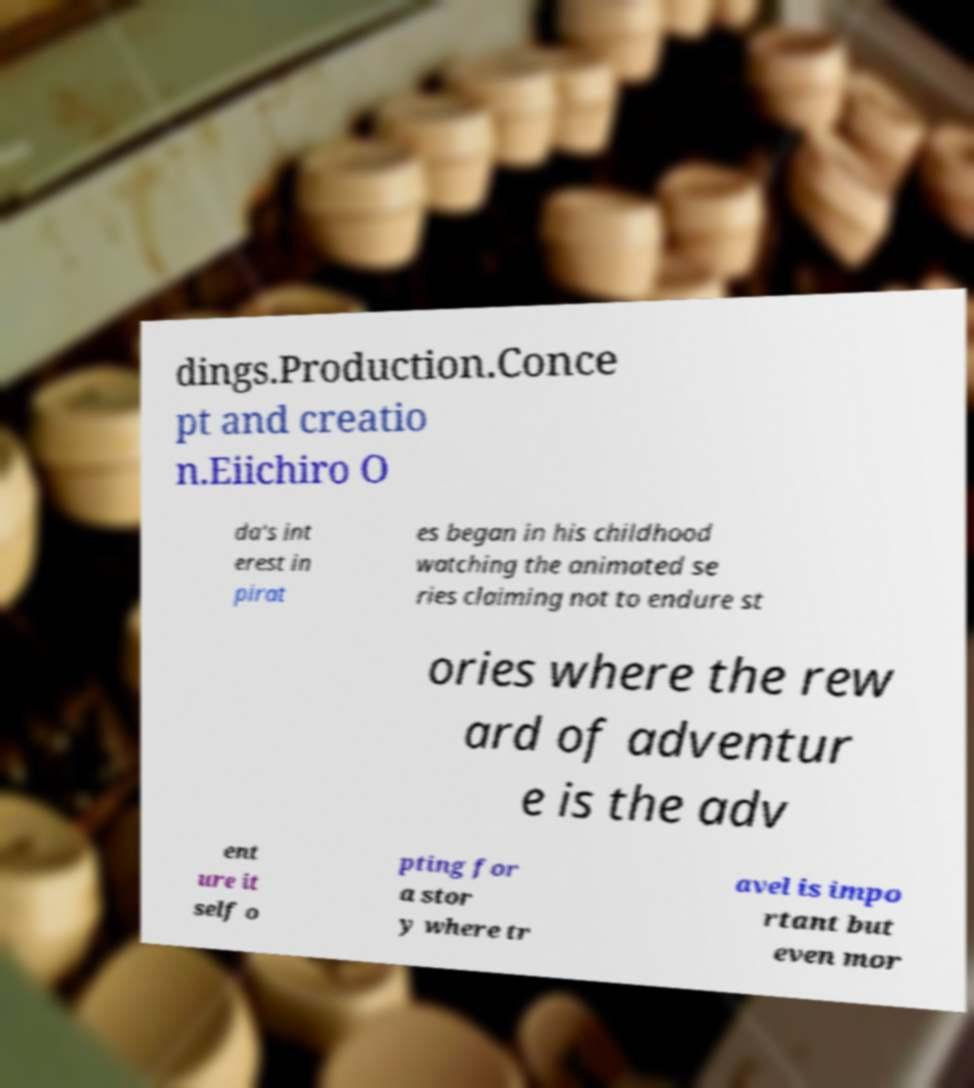Could you extract and type out the text from this image? dings.Production.Conce pt and creatio n.Eiichiro O da's int erest in pirat es began in his childhood watching the animated se ries claiming not to endure st ories where the rew ard of adventur e is the adv ent ure it self o pting for a stor y where tr avel is impo rtant but even mor 